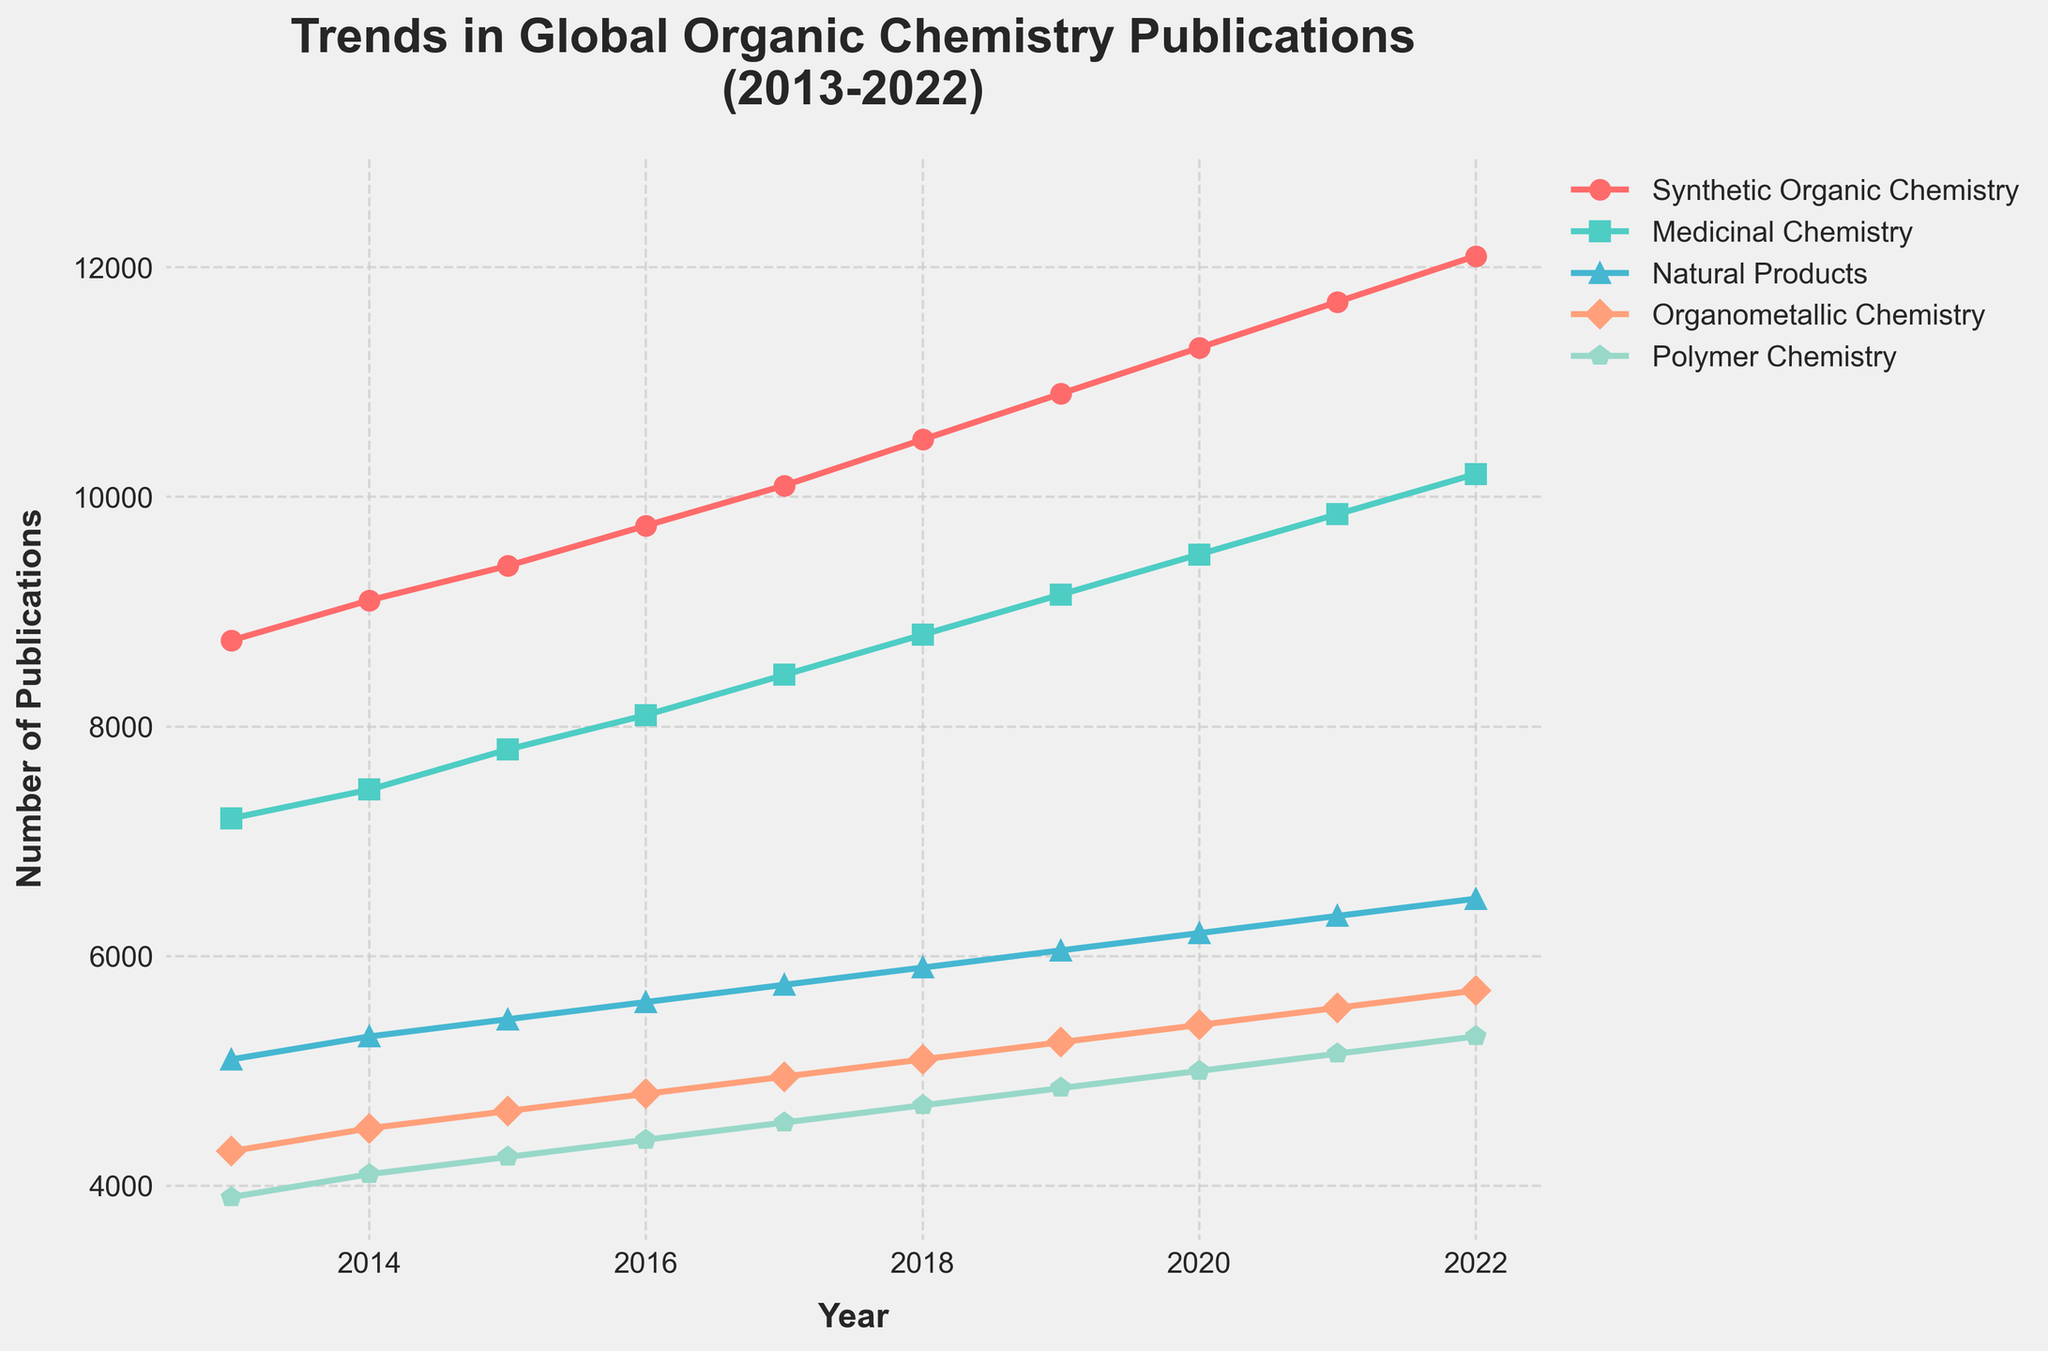Which subfield had the highest number of publications in 2022? Observe the height of the lines at the year 2022. The line for Synthetic Organic Chemistry is at the highest point.
Answer: Synthetic Organic Chemistry How did the number of publications in Medicinal Chemistry change from 2013 to 2016? Compare the vertical position of the Medicinal Chemistry line from 2013 to 2016. It increased from 7200 to 8100.
Answer: Increased by 900 Which subfield showed the smallest growth from 2013 to 2022? Calculate the difference for each subfield from 2013 to 2022: Synthetic Organic Chemistry (12100-8750=3350), Medicinal Chemistry (10200-7200=3000), Natural Products (6500-5100=1400), Organometallic Chemistry (5700-4300=1400), Polymer Chemistry (5300-3900=1400). The smallest growth is for Natural Products, Organometallic Chemistry, and Polymer Chemistry, all increasing by 1400.
Answer: Natural Products, Organometallic Chemistry, Polymer Chemistry What's the average increase per year in publications for Synthetic Organic Chemistry from 2013 to 2022? The total increase from 2013 to 2022 is 12100-8750=3350. There are 9 intervals between 10 years (2013-2022), so the average increase per year is 3350/9.
Answer: 372.22 In which year did Natural Products overtake Organometallic Chemistry in publications? Locate the intersection of the Natural Products and Organometallic Chemistry lines. They intersect halfway between 2017 and 2018.
Answer: 2017-2018 How many total publications were there across all subfields in 2020? Add the number of publications for each subfield in 2020: Synthetic Organic Chemistry (11300), Medicinal Chemistry (9500), Natural Products (6200), Organometallic Chemistry (5400), Polymer Chemistry (5000). The total is 11300 + 9500 + 6200 + 5400 + 5000.
Answer: 37400 Which year saw the highest publication growth for Polymer Chemistry? Examine the Polymer Chemistry line and identify the steepest upward segment. The biggest jump is from 2013 to 2014, with an increase from 3900 to 4100.
Answer: 2013-2014 Between 2014 and 2017, which subfield experienced the most significant increase in publications? Calculate the increase for each subfield from 2014 to 2017: Synthetic Organic Chemistry (10100-9100=1000), Medicinal Chemistry (8450-7450=1000), Natural Products (5750-5300=450), Organometallic Chemistry (4950-4500=450), Polymer Chemistry (4550-4100=450). The most significant increases are for Synthetic Organic Chemistry and Medicinal Chemistry.
Answer: Synthetic Organic Chemistry, Medicinal Chemistry 